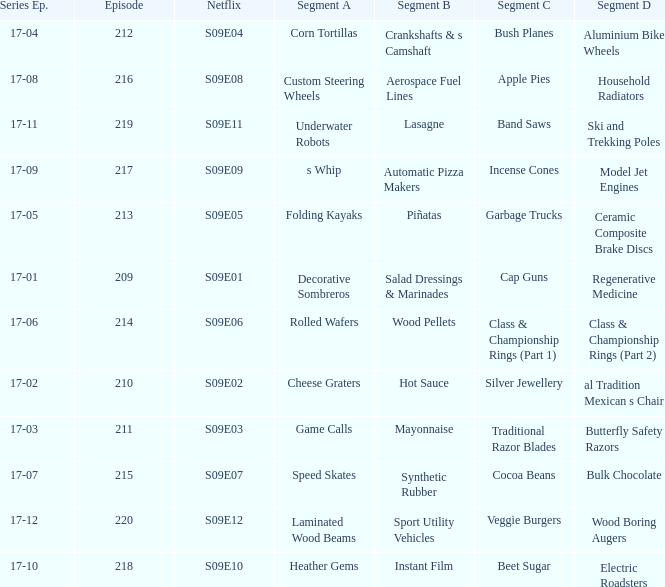For the shows featuring beet sugar, what was on before that Instant Film. 